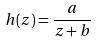Convert formula to latex. <formula><loc_0><loc_0><loc_500><loc_500>h ( z ) = \frac { a } { z + b }</formula> 